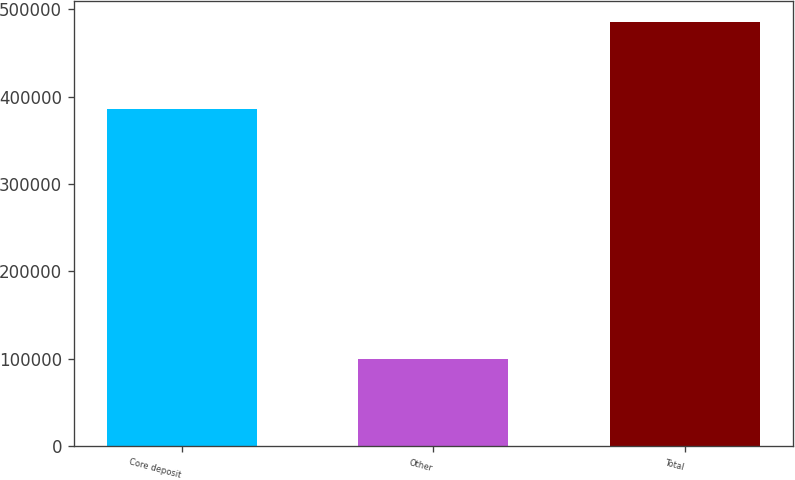Convert chart. <chart><loc_0><loc_0><loc_500><loc_500><bar_chart><fcel>Core deposit<fcel>Other<fcel>Total<nl><fcel>385725<fcel>99530<fcel>485255<nl></chart> 